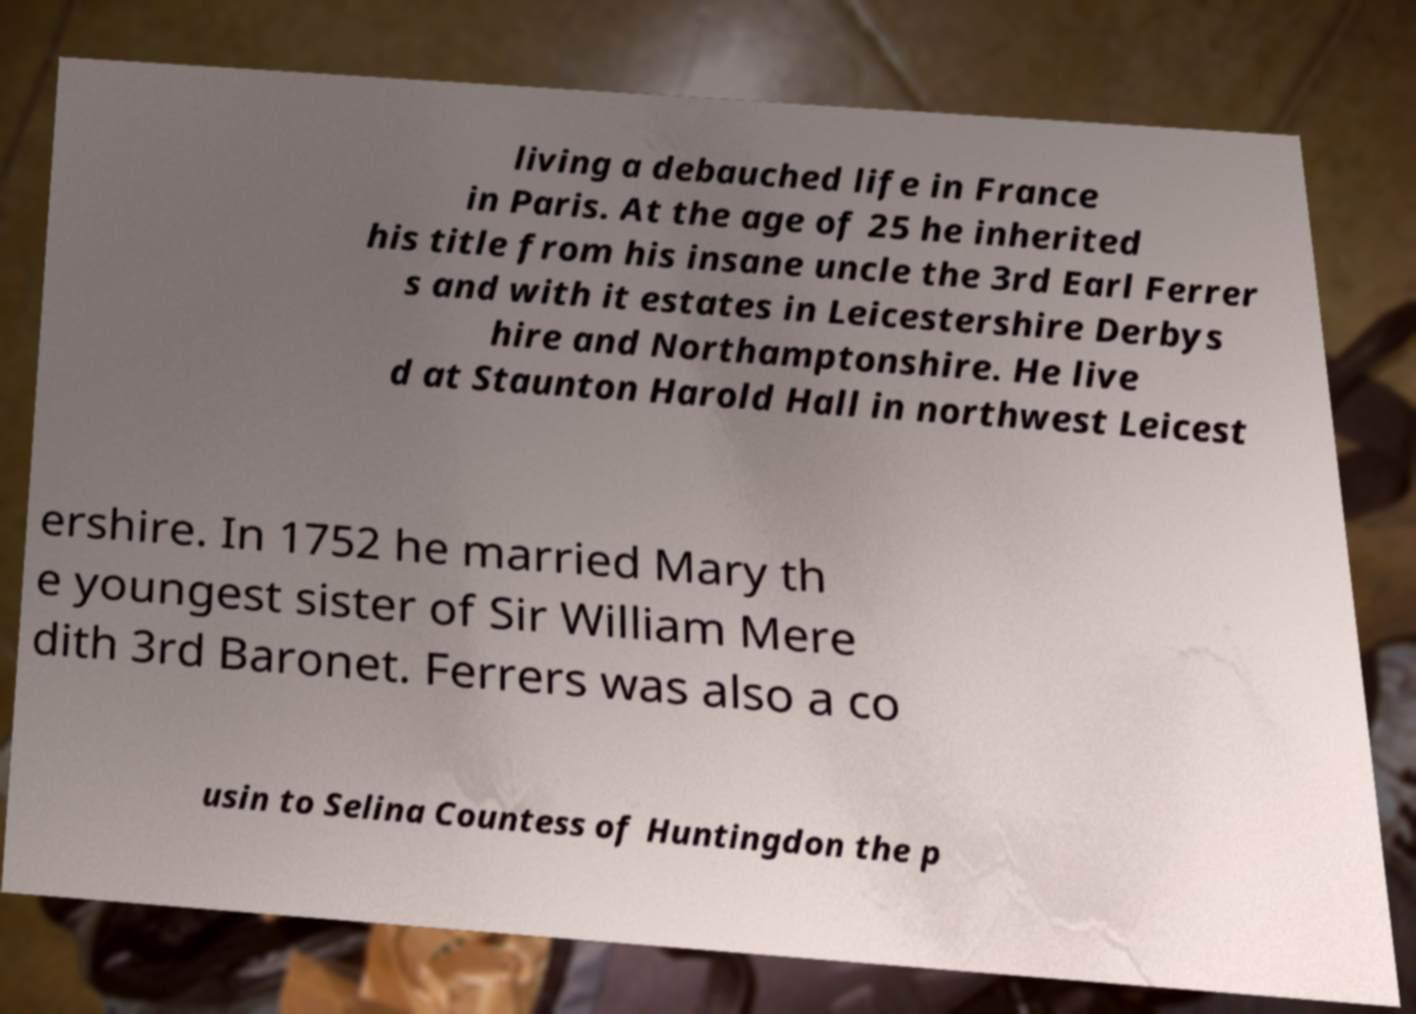Please identify and transcribe the text found in this image. living a debauched life in France in Paris. At the age of 25 he inherited his title from his insane uncle the 3rd Earl Ferrer s and with it estates in Leicestershire Derbys hire and Northamptonshire. He live d at Staunton Harold Hall in northwest Leicest ershire. In 1752 he married Mary th e youngest sister of Sir William Mere dith 3rd Baronet. Ferrers was also a co usin to Selina Countess of Huntingdon the p 